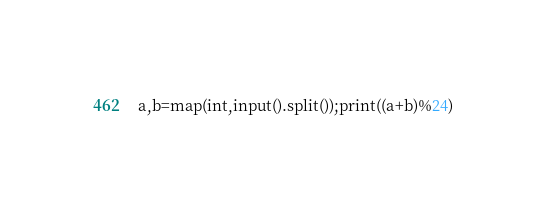<code> <loc_0><loc_0><loc_500><loc_500><_Python_>a,b=map(int,input().split());print((a+b)%24)</code> 